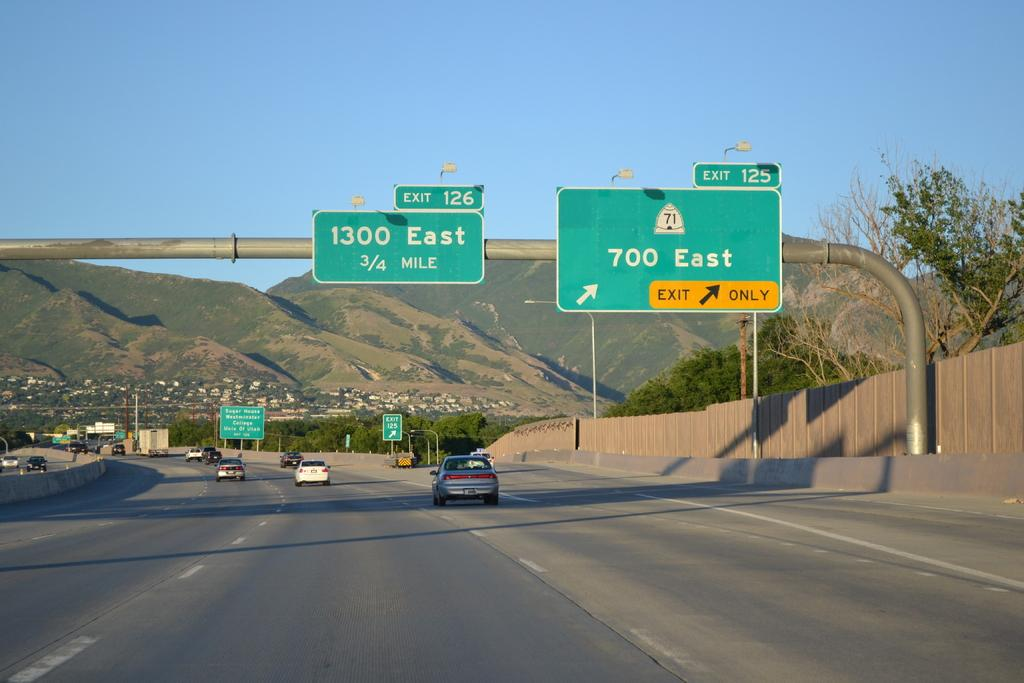<image>
Provide a brief description of the given image. Green road sign that shows 1300 east and 700 east. 